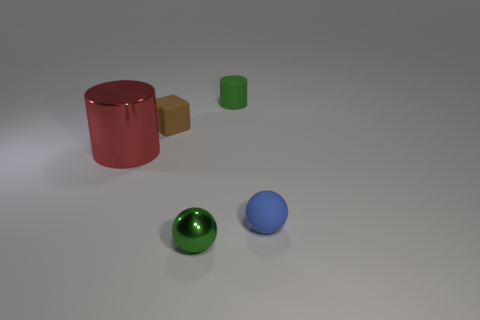Add 5 tiny blue matte objects. How many objects exist? 10 Subtract all cubes. How many objects are left? 4 Add 2 cylinders. How many cylinders are left? 4 Add 4 red metallic cylinders. How many red metallic cylinders exist? 5 Subtract 0 green cubes. How many objects are left? 5 Subtract all gray metallic objects. Subtract all tiny balls. How many objects are left? 3 